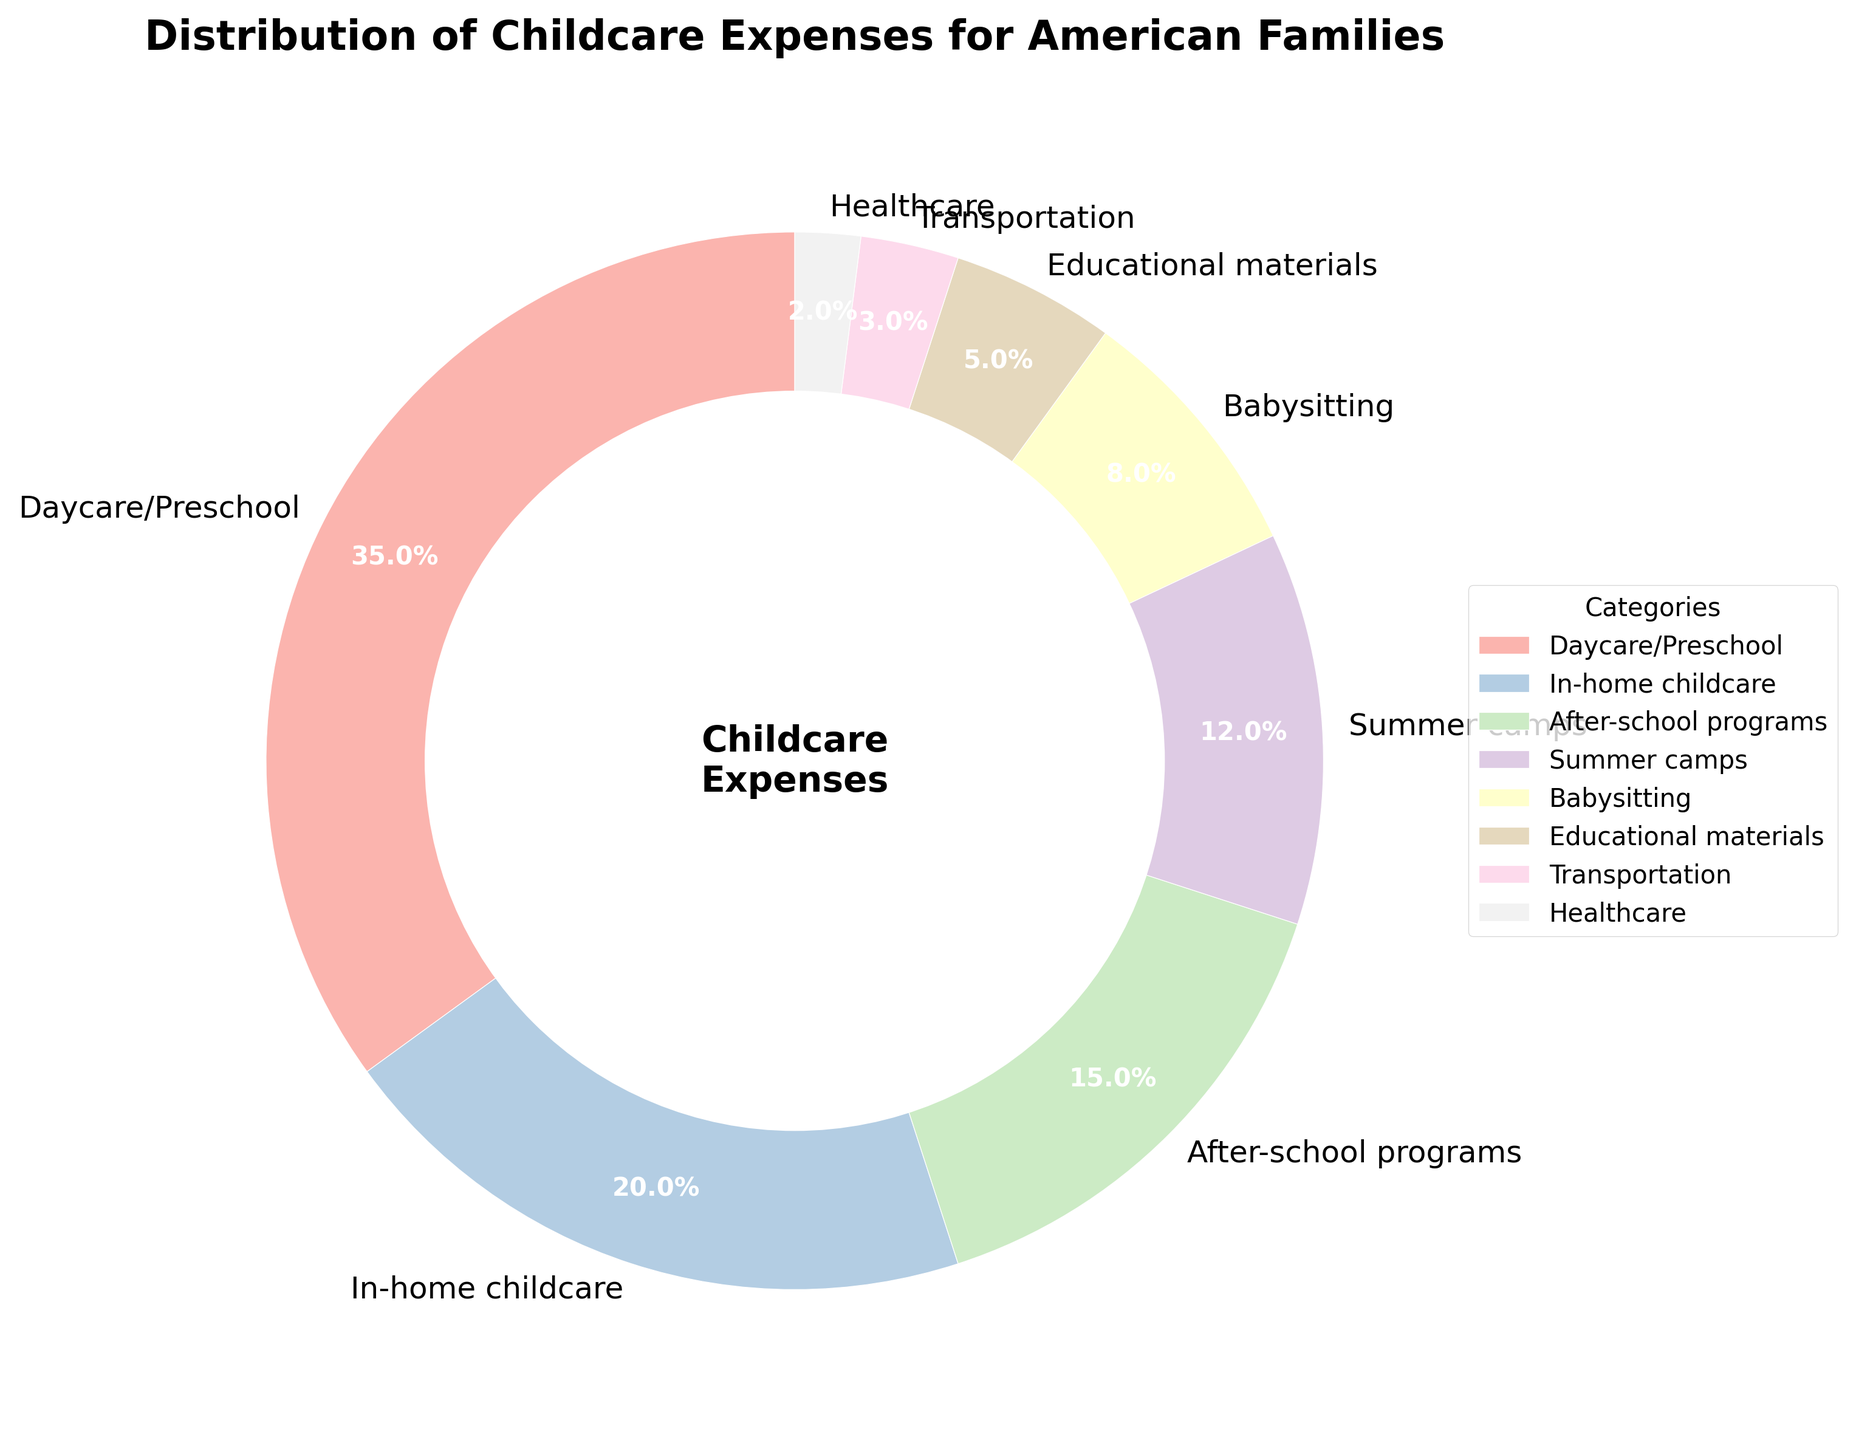How much more is spent on Daycare/Preschool compared to In-home childcare? First, identify the percentages for Daycare/Preschool (35%) and In-home childcare (20%). Then subtract the smaller percentage from the larger one: 35% - 20% = 15%.
Answer: 15% Which category represents the smallest proportion of childcare expenses? Examine the pie chart segments and their labels to find the category with the smallest percentage. Healthcare is marked with the smallest proportion of 2%.
Answer: Healthcare What is the combined percentage of expenses for Babysitting and Transportation? Find the percentages for Babysitting (8%) and Transportation (3%). Then, add them together: 8% + 3% = 11%.
Answer: 11% How does the expense for After-school programs compare to that for Summer camps? Refer to the chart: After-school programs have 15%, and Summer camps have 12%. After-school programs have a higher percentage compared to Summer camps.
Answer: After-school programs are higher What's the total percentage of expenses for categories that involve direct care (Daycare/Preschool, In-home childcare, Babysitting)? Sum the percentages of Daycare/Preschool (35%), In-home childcare (20%), and Babysitting (8%): 35% + 20% + 8% = 63%.
Answer: 63% Which segment in the chart appears largest in size? Visually inspecting the pie chart, the Daycare/Preschool segment appears the largest. It is indicated with the largest wedge and a 35% label.
Answer: Daycare/Preschool Determine the difference in percentage between educational materials and healthcare. Check the percentages: Educational materials (5%) and Healthcare (2%). Subtract the smaller percentage from the larger one: 5% - 2% = 3%.
Answer: 3% What percentage is attributed to programs and camps combined (After-school programs and Summer camps)? Add the percentages of After-school programs (15%) and Summer camps (12%): 15% + 12% = 27%.
Answer: 27% Between In-home childcare and Babysitting, which one takes a larger share of the expenses and by how much? Look at their percentages: In-home childcare (20%) and Babysitting (8%). Subtract the smaller percentage from the larger one: 20% - 8% = 12%.
Answer: In-home childcare by 12% 